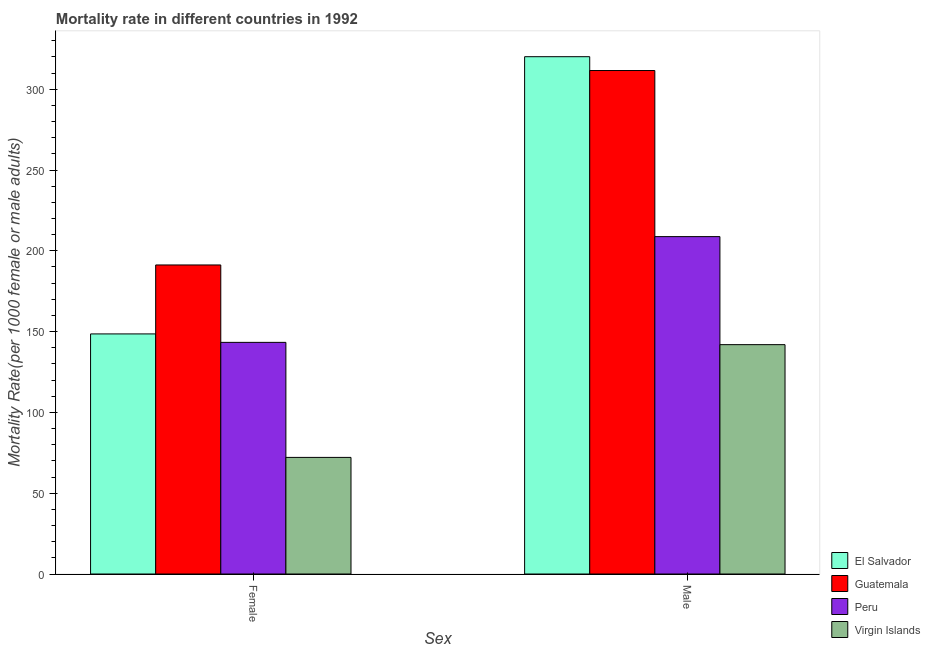Are the number of bars per tick equal to the number of legend labels?
Offer a very short reply. Yes. How many bars are there on the 2nd tick from the right?
Make the answer very short. 4. What is the male mortality rate in Guatemala?
Your response must be concise. 311.57. Across all countries, what is the maximum female mortality rate?
Give a very brief answer. 191.25. Across all countries, what is the minimum female mortality rate?
Offer a terse response. 72.16. In which country was the female mortality rate maximum?
Keep it short and to the point. Guatemala. In which country was the male mortality rate minimum?
Your answer should be very brief. Virgin Islands. What is the total female mortality rate in the graph?
Keep it short and to the point. 555.33. What is the difference between the female mortality rate in Guatemala and that in Peru?
Offer a very short reply. 47.9. What is the difference between the female mortality rate in Virgin Islands and the male mortality rate in Guatemala?
Give a very brief answer. -239.41. What is the average female mortality rate per country?
Your answer should be compact. 138.83. What is the difference between the female mortality rate and male mortality rate in Peru?
Make the answer very short. -65.44. What is the ratio of the male mortality rate in Virgin Islands to that in Guatemala?
Ensure brevity in your answer.  0.46. Is the male mortality rate in El Salvador less than that in Guatemala?
Provide a short and direct response. No. In how many countries, is the male mortality rate greater than the average male mortality rate taken over all countries?
Make the answer very short. 2. What does the 4th bar from the left in Male represents?
Give a very brief answer. Virgin Islands. What does the 3rd bar from the right in Female represents?
Your answer should be very brief. Guatemala. How many bars are there?
Make the answer very short. 8. How many countries are there in the graph?
Give a very brief answer. 4. How are the legend labels stacked?
Provide a succinct answer. Vertical. What is the title of the graph?
Offer a very short reply. Mortality rate in different countries in 1992. Does "Mozambique" appear as one of the legend labels in the graph?
Offer a very short reply. No. What is the label or title of the X-axis?
Offer a terse response. Sex. What is the label or title of the Y-axis?
Make the answer very short. Mortality Rate(per 1000 female or male adults). What is the Mortality Rate(per 1000 female or male adults) in El Salvador in Female?
Offer a very short reply. 148.57. What is the Mortality Rate(per 1000 female or male adults) in Guatemala in Female?
Provide a short and direct response. 191.25. What is the Mortality Rate(per 1000 female or male adults) in Peru in Female?
Your answer should be compact. 143.35. What is the Mortality Rate(per 1000 female or male adults) in Virgin Islands in Female?
Keep it short and to the point. 72.16. What is the Mortality Rate(per 1000 female or male adults) in El Salvador in Male?
Give a very brief answer. 320.14. What is the Mortality Rate(per 1000 female or male adults) in Guatemala in Male?
Provide a succinct answer. 311.57. What is the Mortality Rate(per 1000 female or male adults) of Peru in Male?
Provide a short and direct response. 208.79. What is the Mortality Rate(per 1000 female or male adults) of Virgin Islands in Male?
Ensure brevity in your answer.  141.93. Across all Sex, what is the maximum Mortality Rate(per 1000 female or male adults) in El Salvador?
Ensure brevity in your answer.  320.14. Across all Sex, what is the maximum Mortality Rate(per 1000 female or male adults) of Guatemala?
Offer a terse response. 311.57. Across all Sex, what is the maximum Mortality Rate(per 1000 female or male adults) in Peru?
Your answer should be very brief. 208.79. Across all Sex, what is the maximum Mortality Rate(per 1000 female or male adults) of Virgin Islands?
Keep it short and to the point. 141.93. Across all Sex, what is the minimum Mortality Rate(per 1000 female or male adults) of El Salvador?
Offer a very short reply. 148.57. Across all Sex, what is the minimum Mortality Rate(per 1000 female or male adults) of Guatemala?
Your answer should be compact. 191.25. Across all Sex, what is the minimum Mortality Rate(per 1000 female or male adults) of Peru?
Ensure brevity in your answer.  143.35. Across all Sex, what is the minimum Mortality Rate(per 1000 female or male adults) of Virgin Islands?
Offer a very short reply. 72.16. What is the total Mortality Rate(per 1000 female or male adults) in El Salvador in the graph?
Make the answer very short. 468.71. What is the total Mortality Rate(per 1000 female or male adults) of Guatemala in the graph?
Provide a short and direct response. 502.82. What is the total Mortality Rate(per 1000 female or male adults) in Peru in the graph?
Offer a terse response. 352.13. What is the total Mortality Rate(per 1000 female or male adults) in Virgin Islands in the graph?
Offer a terse response. 214.09. What is the difference between the Mortality Rate(per 1000 female or male adults) of El Salvador in Female and that in Male?
Provide a succinct answer. -171.56. What is the difference between the Mortality Rate(per 1000 female or male adults) in Guatemala in Female and that in Male?
Your answer should be very brief. -120.33. What is the difference between the Mortality Rate(per 1000 female or male adults) in Peru in Female and that in Male?
Provide a succinct answer. -65.44. What is the difference between the Mortality Rate(per 1000 female or male adults) of Virgin Islands in Female and that in Male?
Your answer should be very brief. -69.77. What is the difference between the Mortality Rate(per 1000 female or male adults) of El Salvador in Female and the Mortality Rate(per 1000 female or male adults) of Guatemala in Male?
Your answer should be very brief. -163. What is the difference between the Mortality Rate(per 1000 female or male adults) of El Salvador in Female and the Mortality Rate(per 1000 female or male adults) of Peru in Male?
Provide a short and direct response. -60.22. What is the difference between the Mortality Rate(per 1000 female or male adults) in El Salvador in Female and the Mortality Rate(per 1000 female or male adults) in Virgin Islands in Male?
Provide a succinct answer. 6.64. What is the difference between the Mortality Rate(per 1000 female or male adults) in Guatemala in Female and the Mortality Rate(per 1000 female or male adults) in Peru in Male?
Keep it short and to the point. -17.54. What is the difference between the Mortality Rate(per 1000 female or male adults) in Guatemala in Female and the Mortality Rate(per 1000 female or male adults) in Virgin Islands in Male?
Provide a succinct answer. 49.31. What is the difference between the Mortality Rate(per 1000 female or male adults) in Peru in Female and the Mortality Rate(per 1000 female or male adults) in Virgin Islands in Male?
Give a very brief answer. 1.41. What is the average Mortality Rate(per 1000 female or male adults) of El Salvador per Sex?
Your answer should be very brief. 234.36. What is the average Mortality Rate(per 1000 female or male adults) of Guatemala per Sex?
Offer a terse response. 251.41. What is the average Mortality Rate(per 1000 female or male adults) of Peru per Sex?
Your response must be concise. 176.07. What is the average Mortality Rate(per 1000 female or male adults) in Virgin Islands per Sex?
Ensure brevity in your answer.  107.05. What is the difference between the Mortality Rate(per 1000 female or male adults) in El Salvador and Mortality Rate(per 1000 female or male adults) in Guatemala in Female?
Provide a succinct answer. -42.67. What is the difference between the Mortality Rate(per 1000 female or male adults) in El Salvador and Mortality Rate(per 1000 female or male adults) in Peru in Female?
Provide a short and direct response. 5.23. What is the difference between the Mortality Rate(per 1000 female or male adults) in El Salvador and Mortality Rate(per 1000 female or male adults) in Virgin Islands in Female?
Ensure brevity in your answer.  76.41. What is the difference between the Mortality Rate(per 1000 female or male adults) of Guatemala and Mortality Rate(per 1000 female or male adults) of Peru in Female?
Offer a very short reply. 47.9. What is the difference between the Mortality Rate(per 1000 female or male adults) of Guatemala and Mortality Rate(per 1000 female or male adults) of Virgin Islands in Female?
Offer a terse response. 119.08. What is the difference between the Mortality Rate(per 1000 female or male adults) of Peru and Mortality Rate(per 1000 female or male adults) of Virgin Islands in Female?
Give a very brief answer. 71.19. What is the difference between the Mortality Rate(per 1000 female or male adults) in El Salvador and Mortality Rate(per 1000 female or male adults) in Guatemala in Male?
Make the answer very short. 8.56. What is the difference between the Mortality Rate(per 1000 female or male adults) of El Salvador and Mortality Rate(per 1000 female or male adults) of Peru in Male?
Ensure brevity in your answer.  111.35. What is the difference between the Mortality Rate(per 1000 female or male adults) in El Salvador and Mortality Rate(per 1000 female or male adults) in Virgin Islands in Male?
Give a very brief answer. 178.2. What is the difference between the Mortality Rate(per 1000 female or male adults) of Guatemala and Mortality Rate(per 1000 female or male adults) of Peru in Male?
Keep it short and to the point. 102.78. What is the difference between the Mortality Rate(per 1000 female or male adults) in Guatemala and Mortality Rate(per 1000 female or male adults) in Virgin Islands in Male?
Provide a short and direct response. 169.64. What is the difference between the Mortality Rate(per 1000 female or male adults) in Peru and Mortality Rate(per 1000 female or male adults) in Virgin Islands in Male?
Ensure brevity in your answer.  66.86. What is the ratio of the Mortality Rate(per 1000 female or male adults) in El Salvador in Female to that in Male?
Provide a short and direct response. 0.46. What is the ratio of the Mortality Rate(per 1000 female or male adults) in Guatemala in Female to that in Male?
Your answer should be compact. 0.61. What is the ratio of the Mortality Rate(per 1000 female or male adults) in Peru in Female to that in Male?
Keep it short and to the point. 0.69. What is the ratio of the Mortality Rate(per 1000 female or male adults) in Virgin Islands in Female to that in Male?
Your response must be concise. 0.51. What is the difference between the highest and the second highest Mortality Rate(per 1000 female or male adults) of El Salvador?
Offer a very short reply. 171.56. What is the difference between the highest and the second highest Mortality Rate(per 1000 female or male adults) of Guatemala?
Your answer should be very brief. 120.33. What is the difference between the highest and the second highest Mortality Rate(per 1000 female or male adults) of Peru?
Your answer should be very brief. 65.44. What is the difference between the highest and the second highest Mortality Rate(per 1000 female or male adults) of Virgin Islands?
Offer a terse response. 69.77. What is the difference between the highest and the lowest Mortality Rate(per 1000 female or male adults) in El Salvador?
Ensure brevity in your answer.  171.56. What is the difference between the highest and the lowest Mortality Rate(per 1000 female or male adults) in Guatemala?
Offer a terse response. 120.33. What is the difference between the highest and the lowest Mortality Rate(per 1000 female or male adults) of Peru?
Offer a very short reply. 65.44. What is the difference between the highest and the lowest Mortality Rate(per 1000 female or male adults) in Virgin Islands?
Offer a terse response. 69.77. 